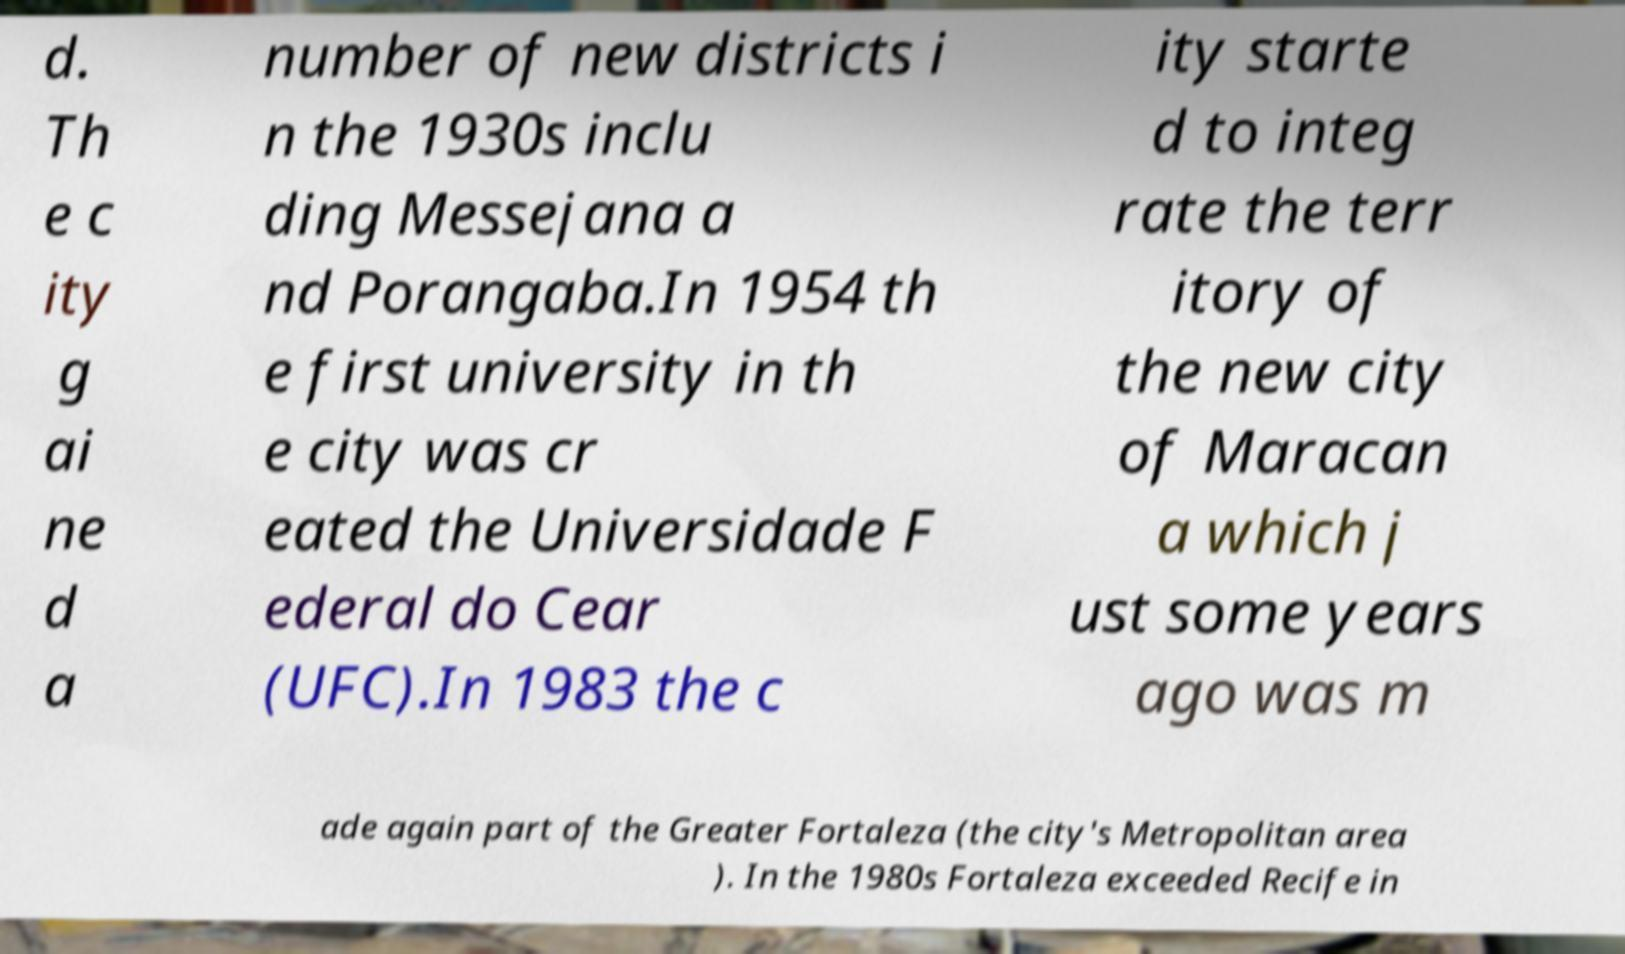Could you assist in decoding the text presented in this image and type it out clearly? d. Th e c ity g ai ne d a number of new districts i n the 1930s inclu ding Messejana a nd Porangaba.In 1954 th e first university in th e city was cr eated the Universidade F ederal do Cear (UFC).In 1983 the c ity starte d to integ rate the terr itory of the new city of Maracan a which j ust some years ago was m ade again part of the Greater Fortaleza (the city's Metropolitan area ). In the 1980s Fortaleza exceeded Recife in 